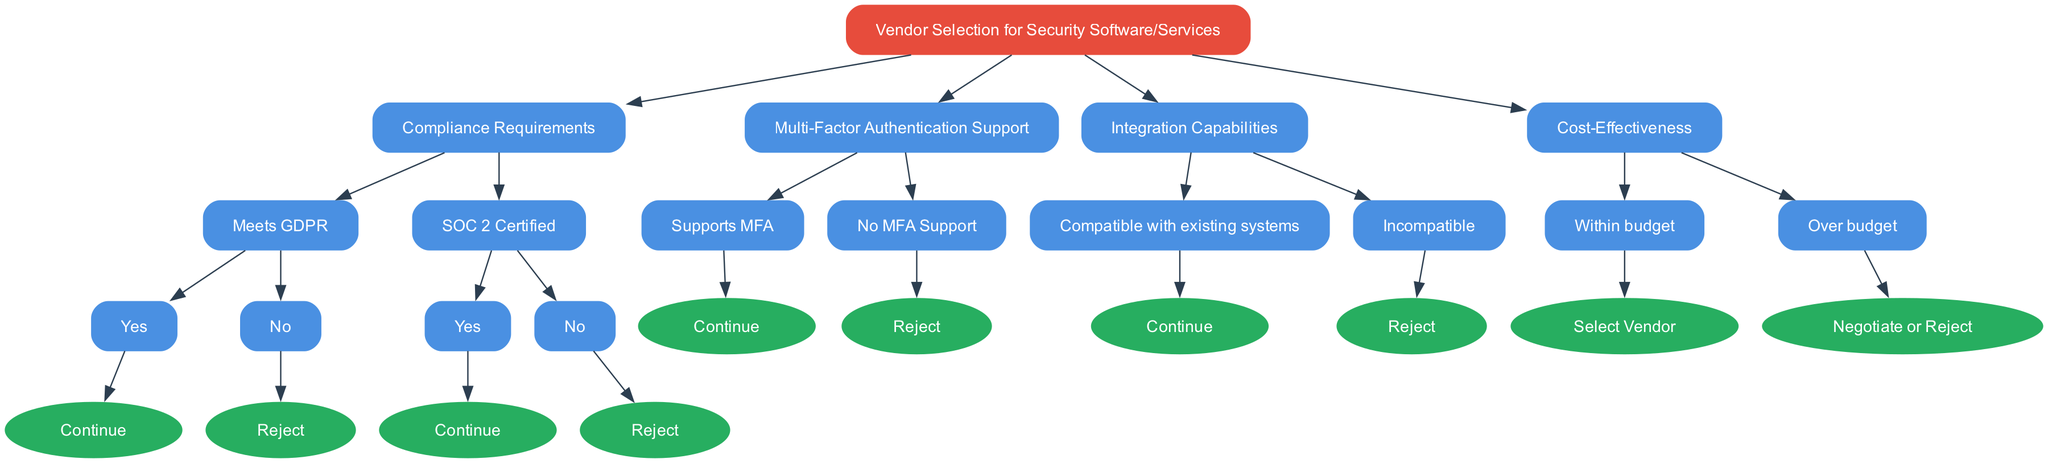What is the root node of the decision tree? The root node of the decision tree, which represents the starting point of the vendor selection process, is labeled "Vendor Selection for Security Software/Services".
Answer: Vendor Selection for Security Software/Services How many compliance requirements does the diagram specify? The diagram specifies two compliance requirements: "Meets GDPR" and "SOC 2 Certified". These are the child nodes under the "Compliance Requirements" node.
Answer: 2 What happens if the vendor does not meet GDPR requirements? If the vendor does not meet GDPR requirements, the flow leads to a "Reject" decision, indicating the vendor is not suitable for selection.
Answer: Reject Does the decision tree include Multi-Factor Authentication support as a criterion? Yes, the decision tree includes "Multi-Factor Authentication Support" as a criterion which branches into options for support and no support.
Answer: Yes What is the outcome if a vendor is not compliant with existing systems? If a vendor is incompatible with existing systems, the decision tree will lead to a "Reject" outcome, meaning the vendor is not an acceptable option.
Answer: Reject How is cost-effectiveness evaluated in the decision tree? Cost-effectiveness is evaluated through a comparison of the vendor's pricing to the budget; if the vendor is within budget, they are selected, otherwise, a negotiation or rejection occurs.
Answer: Within budget What is the flow path if a vendor meets both GDPR and SOC 2 requirements? If a vendor meets both GDPR and SOC 2 requirements, the flow will continue from the "Compliance Requirements" section, leading to further evaluation of Multi-Factor Authentication support.
Answer: Continue What is the final decision if the selected vendor is over budget? If the selected vendor is over budget, the decision tree indicates to "Negotiate or Reject", which allows for either negotiation for better pricing or outright rejection of the vendor.
Answer: Negotiate or Reject 